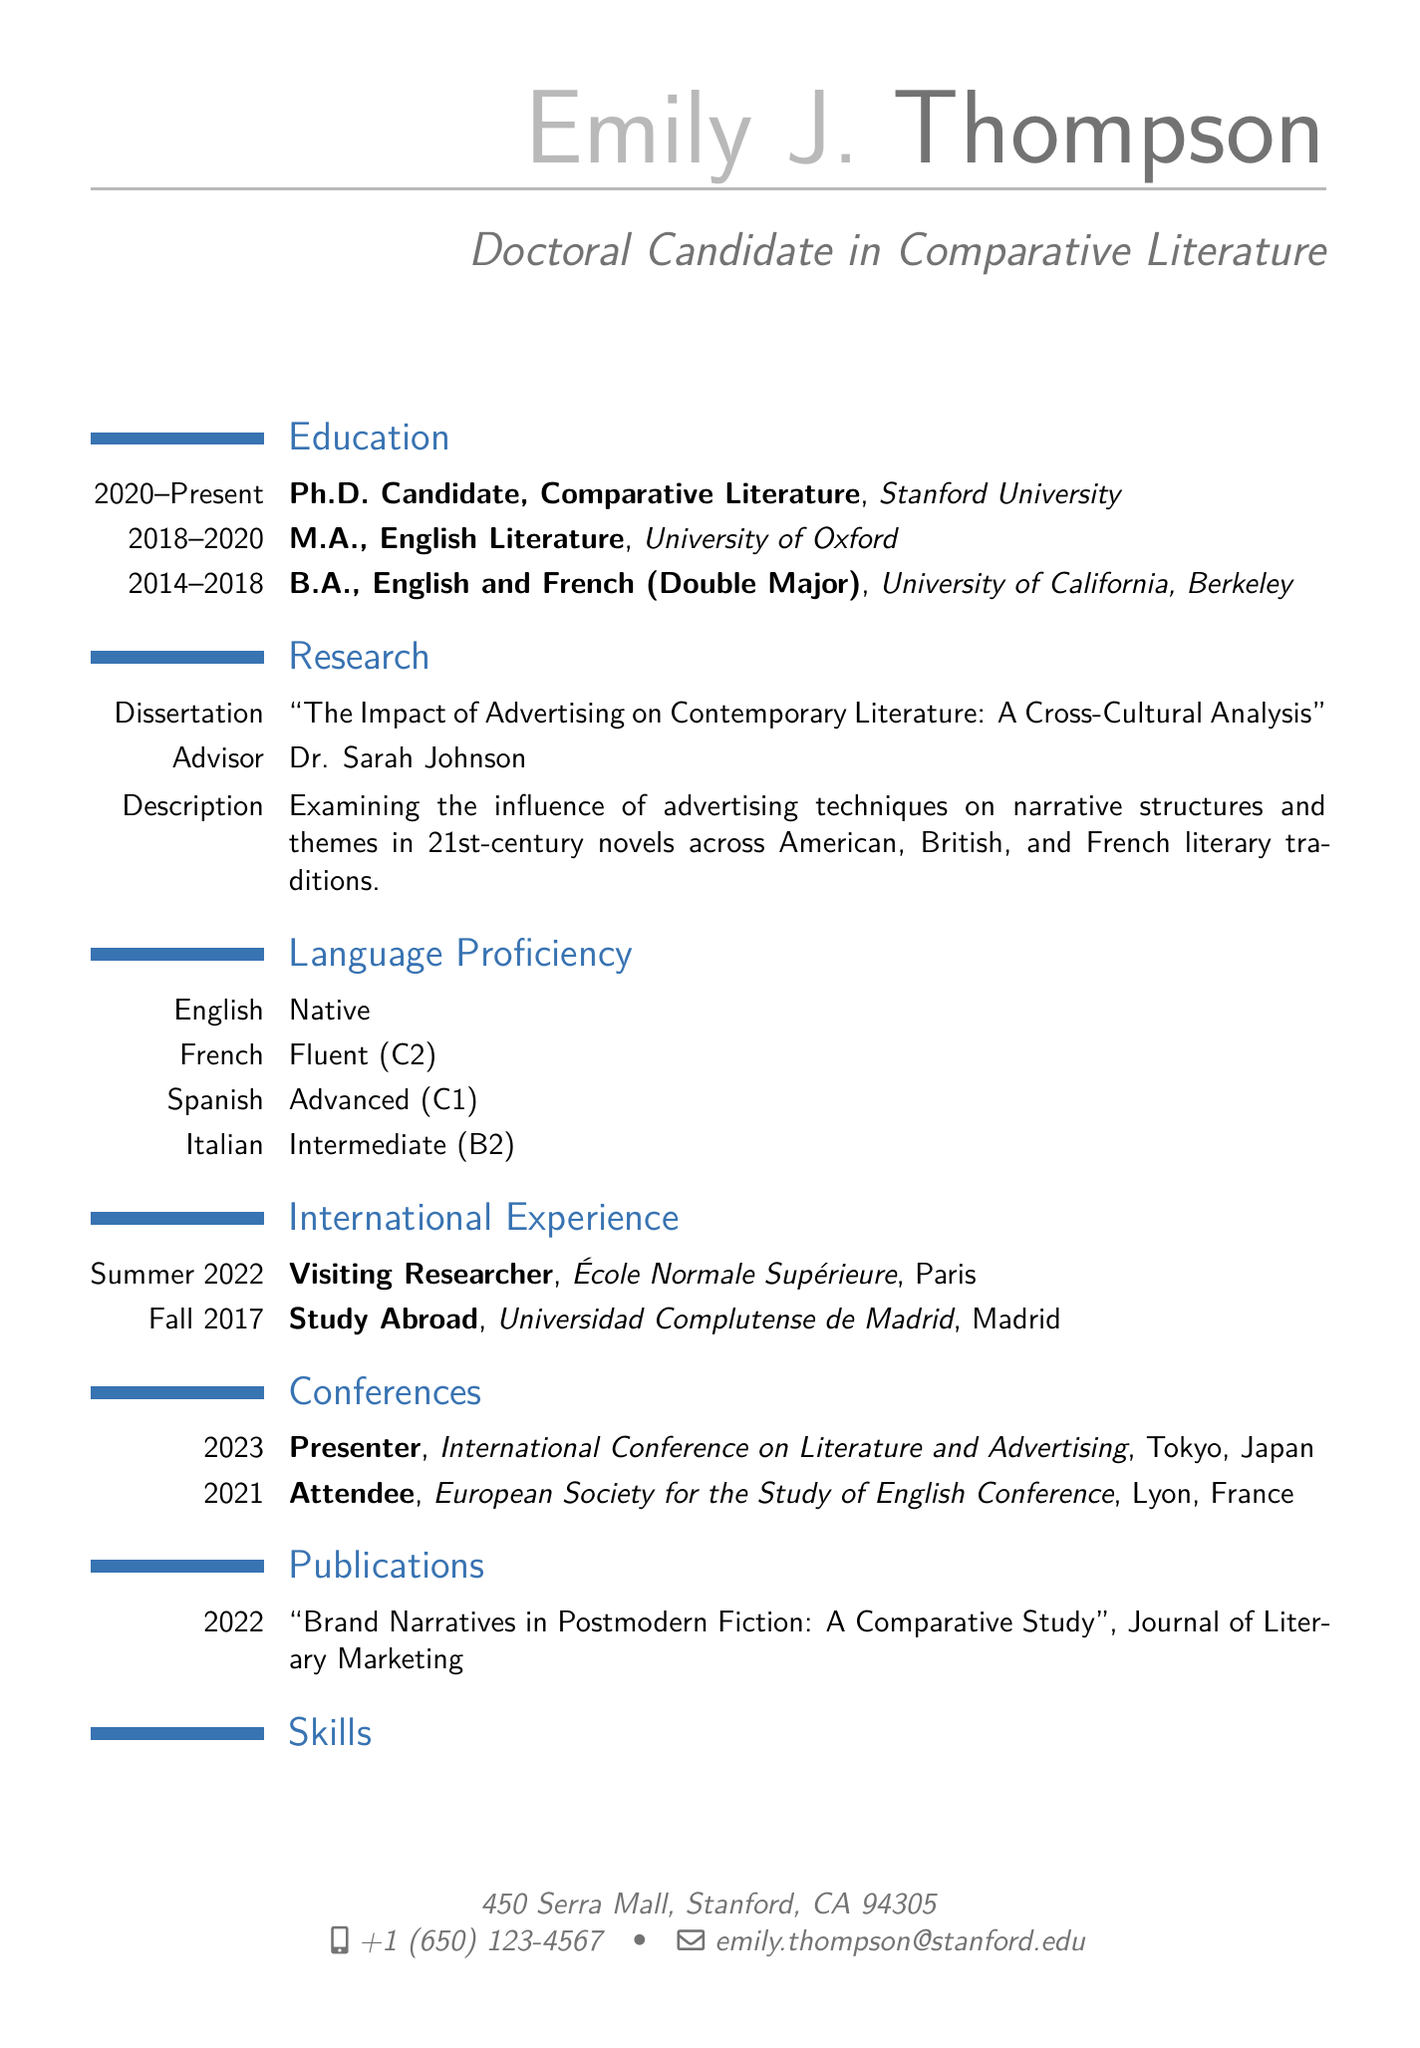What is Emily J. Thompson's current degree? The current degree is listed under education as "Ph.D. Candidate, Comparative Literature."
Answer: Ph.D. Candidate, Comparative Literature What year did Emily obtain her M.A. degree? The M.A. degree was completed from 2018 to 2020, indicating the end year is 2020.
Answer: 2020 Which languages does Emily speak at a native level? The document specifies that English is the only language listed at the native level.
Answer: English How long did Emily spend as a Visiting Researcher? The duration for the Visiting Researcher program is stated as "Summer 2022". Summer typically represents a season, rather than a specific duration like months.
Answer: Summer 2022 What is the title of Emily's dissertation? The dissertation title is provided under the research section.
Answer: The Impact of Advertising on Contemporary Literature: A Cross-Cultural Analysis In which country did Emily present her research in 2023? The conference location is mentioned as Tokyo, Japan, where she presented her research in 2023.
Answer: Japan What level of proficiency does Emily have in Spanish? The document specifies Spanish proficiency as "Advanced (C1)."
Answer: Advanced (C1) What university did Emily attend for her undergraduate degree? The B.A. degree is from the University of California, Berkeley.
Answer: University of California, Berkeley At which conference did Emily attend in 2021? The conference listed for 2021 is the "European Society for the Study of English Conference."
Answer: European Society for the Study of English Conference 